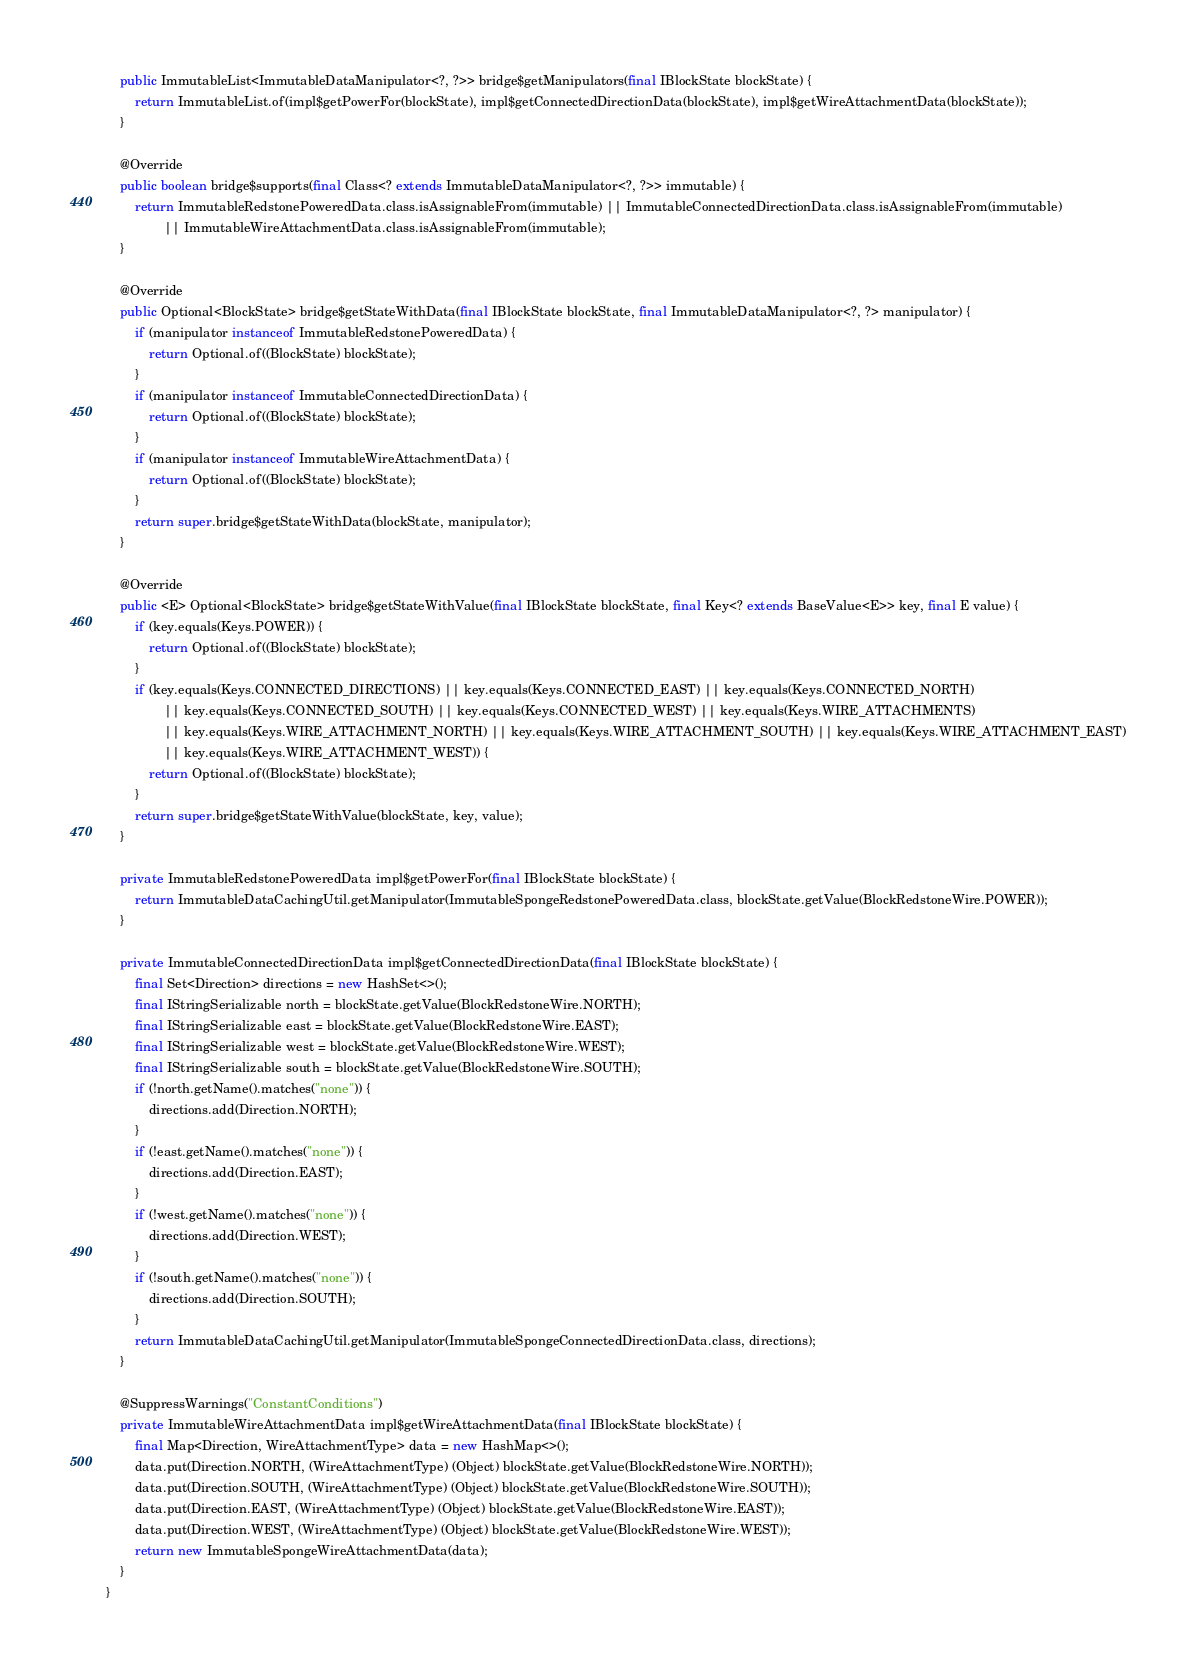<code> <loc_0><loc_0><loc_500><loc_500><_Java_>    public ImmutableList<ImmutableDataManipulator<?, ?>> bridge$getManipulators(final IBlockState blockState) {
        return ImmutableList.of(impl$getPowerFor(blockState), impl$getConnectedDirectionData(blockState), impl$getWireAttachmentData(blockState));
    }

    @Override
    public boolean bridge$supports(final Class<? extends ImmutableDataManipulator<?, ?>> immutable) {
        return ImmutableRedstonePoweredData.class.isAssignableFrom(immutable) || ImmutableConnectedDirectionData.class.isAssignableFrom(immutable)
                || ImmutableWireAttachmentData.class.isAssignableFrom(immutable);
    }

    @Override
    public Optional<BlockState> bridge$getStateWithData(final IBlockState blockState, final ImmutableDataManipulator<?, ?> manipulator) {
        if (manipulator instanceof ImmutableRedstonePoweredData) {
            return Optional.of((BlockState) blockState);
        }
        if (manipulator instanceof ImmutableConnectedDirectionData) {
            return Optional.of((BlockState) blockState);
        }
        if (manipulator instanceof ImmutableWireAttachmentData) {
            return Optional.of((BlockState) blockState);
        }
        return super.bridge$getStateWithData(blockState, manipulator);
    }

    @Override
    public <E> Optional<BlockState> bridge$getStateWithValue(final IBlockState blockState, final Key<? extends BaseValue<E>> key, final E value) {
        if (key.equals(Keys.POWER)) {
            return Optional.of((BlockState) blockState);
        }
        if (key.equals(Keys.CONNECTED_DIRECTIONS) || key.equals(Keys.CONNECTED_EAST) || key.equals(Keys.CONNECTED_NORTH)
                || key.equals(Keys.CONNECTED_SOUTH) || key.equals(Keys.CONNECTED_WEST) || key.equals(Keys.WIRE_ATTACHMENTS)
                || key.equals(Keys.WIRE_ATTACHMENT_NORTH) || key.equals(Keys.WIRE_ATTACHMENT_SOUTH) || key.equals(Keys.WIRE_ATTACHMENT_EAST)
                || key.equals(Keys.WIRE_ATTACHMENT_WEST)) {
            return Optional.of((BlockState) blockState);
        }
        return super.bridge$getStateWithValue(blockState, key, value);
    }

    private ImmutableRedstonePoweredData impl$getPowerFor(final IBlockState blockState) {
        return ImmutableDataCachingUtil.getManipulator(ImmutableSpongeRedstonePoweredData.class, blockState.getValue(BlockRedstoneWire.POWER));
    }

    private ImmutableConnectedDirectionData impl$getConnectedDirectionData(final IBlockState blockState) {
        final Set<Direction> directions = new HashSet<>();
        final IStringSerializable north = blockState.getValue(BlockRedstoneWire.NORTH);
        final IStringSerializable east = blockState.getValue(BlockRedstoneWire.EAST);
        final IStringSerializable west = blockState.getValue(BlockRedstoneWire.WEST);
        final IStringSerializable south = blockState.getValue(BlockRedstoneWire.SOUTH);
        if (!north.getName().matches("none")) {
            directions.add(Direction.NORTH);
        }
        if (!east.getName().matches("none")) {
            directions.add(Direction.EAST);
        }
        if (!west.getName().matches("none")) {
            directions.add(Direction.WEST);
        }
        if (!south.getName().matches("none")) {
            directions.add(Direction.SOUTH);
        }
        return ImmutableDataCachingUtil.getManipulator(ImmutableSpongeConnectedDirectionData.class, directions);
    }

    @SuppressWarnings("ConstantConditions")
    private ImmutableWireAttachmentData impl$getWireAttachmentData(final IBlockState blockState) {
        final Map<Direction, WireAttachmentType> data = new HashMap<>();
        data.put(Direction.NORTH, (WireAttachmentType) (Object) blockState.getValue(BlockRedstoneWire.NORTH));
        data.put(Direction.SOUTH, (WireAttachmentType) (Object) blockState.getValue(BlockRedstoneWire.SOUTH));
        data.put(Direction.EAST, (WireAttachmentType) (Object) blockState.getValue(BlockRedstoneWire.EAST));
        data.put(Direction.WEST, (WireAttachmentType) (Object) blockState.getValue(BlockRedstoneWire.WEST));
        return new ImmutableSpongeWireAttachmentData(data);
    }
}
</code> 